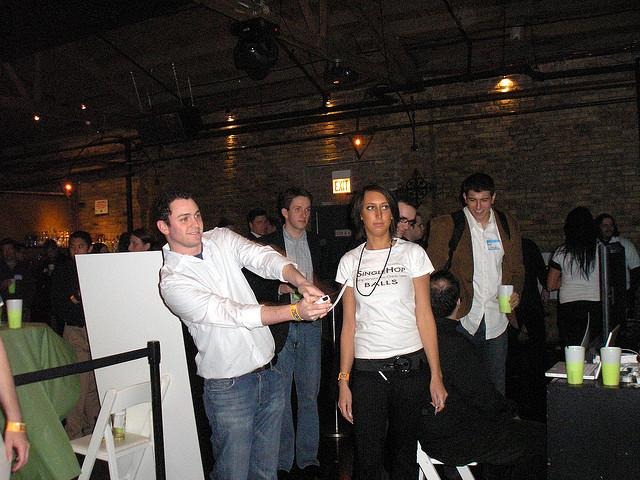Why is the man swinging his arm?

Choices:
A) to wave
B) to hit
C) to exercise
D) to control to control 